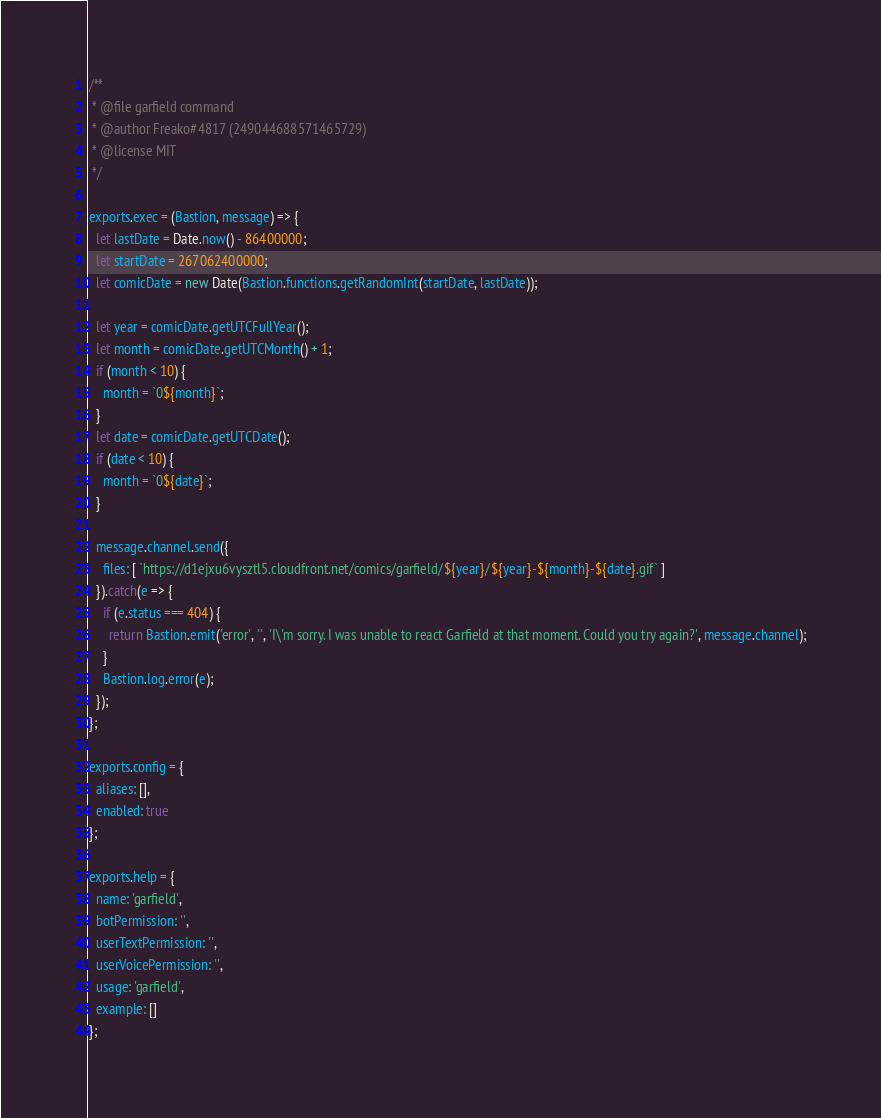Convert code to text. <code><loc_0><loc_0><loc_500><loc_500><_JavaScript_>/**
 * @file garfield command
 * @author Freako#4817 (249044688571465729)
 * @license MIT
 */

exports.exec = (Bastion, message) => {
  let lastDate = Date.now() - 86400000;
  let startDate = 267062400000;
  let comicDate = new Date(Bastion.functions.getRandomInt(startDate, lastDate));

  let year = comicDate.getUTCFullYear();
  let month = comicDate.getUTCMonth() + 1;
  if (month < 10) {
    month = `0${month}`;
  }
  let date = comicDate.getUTCDate();
  if (date < 10) {
    month = `0${date}`;
  }

  message.channel.send({
    files: [ `https://d1ejxu6vysztl5.cloudfront.net/comics/garfield/${year}/${year}-${month}-${date}.gif` ]
  }).catch(e => {
    if (e.status === 404) {
      return Bastion.emit('error', '', 'I\'m sorry. I was unable to react Garfield at that moment. Could you try again?', message.channel);
    }
    Bastion.log.error(e);
  });
};

exports.config = {
  aliases: [],
  enabled: true
};

exports.help = {
  name: 'garfield',
  botPermission: '',
  userTextPermission: '',
  userVoicePermission: '',
  usage: 'garfield',
  example: []
};
</code> 